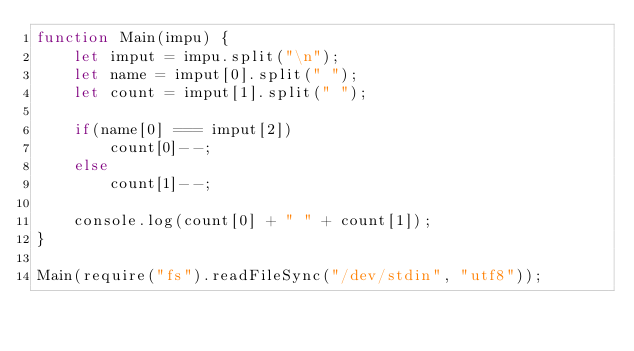<code> <loc_0><loc_0><loc_500><loc_500><_JavaScript_>function Main(impu) {
	let imput = impu.split("\n");
	let name = imput[0].split(" ");
	let count = imput[1].split(" ");
	
	if(name[0] === imput[2]) 
		count[0]--;
	else
		count[1]--;
	
	console.log(count[0] + " " + count[1]);
}

Main(require("fs").readFileSync("/dev/stdin", "utf8"));</code> 